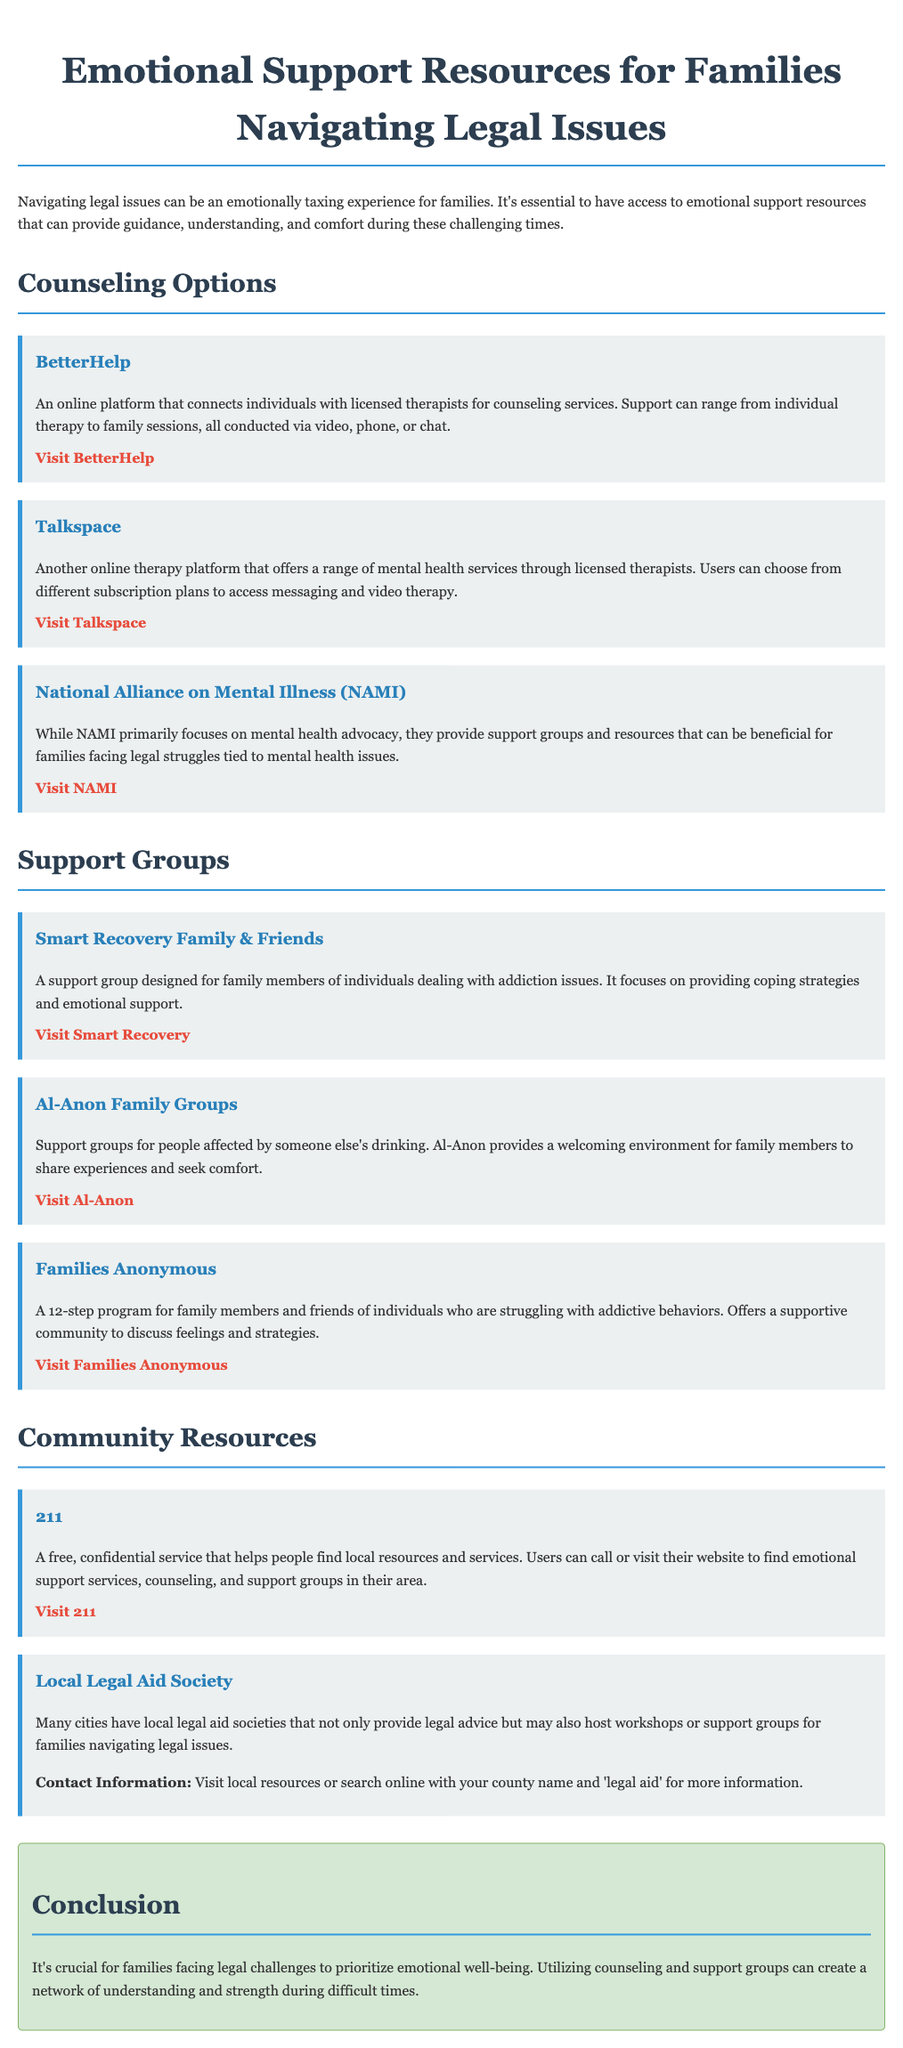What is the title of the document? The title is mentioned at the beginning of the document, formatting the main topic.
Answer: Emotional Support Resources for Families Navigating Legal Issues What online platform connects individuals with licensed therapists? The document lists BetterHelp as a resource for counseling services.
Answer: BetterHelp What type of support group does Smart Recovery Family & Friends provide? The document specifies that it is designed for family members dealing with addiction issues.
Answer: Addiction How can users reach local resources through 211? The document notes that 211 is a free, confidential service available by phone or website.
Answer: Phone or website What is Al-Anon focused on? The document describes Al-Anon as support groups for those affected by someone else's drinking.
Answer: Support for drinking Name one organization that primarily focuses on mental health advocacy. The document mentions NAMI, which provides support groups for families facing legal struggles tied to mental health.
Answer: NAMI What type of program is Families Anonymous based on? The document indicates that Families Anonymous is a 12-step program for family members.
Answer: 12-step What can local legal aid societies provide in addition to legal advice? According to the document, local legal aid societies may also host workshops or support groups for families.
Answer: Workshops or support groups Which resource provides both emotional support services and legal advice? The document describes local legal aid societies as offering both types of services.
Answer: Local Legal Aid Society 